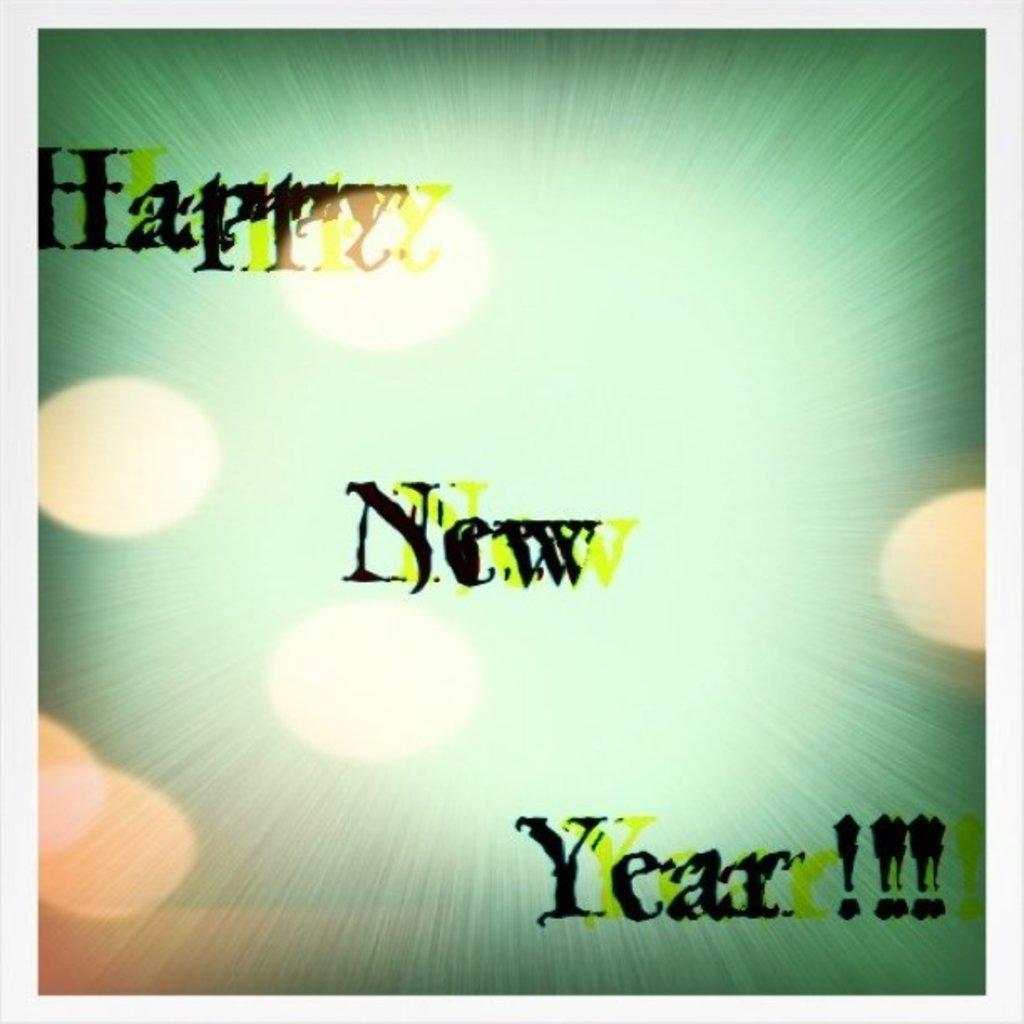What does this picture say?
Provide a short and direct response. Happy new year!!!. 